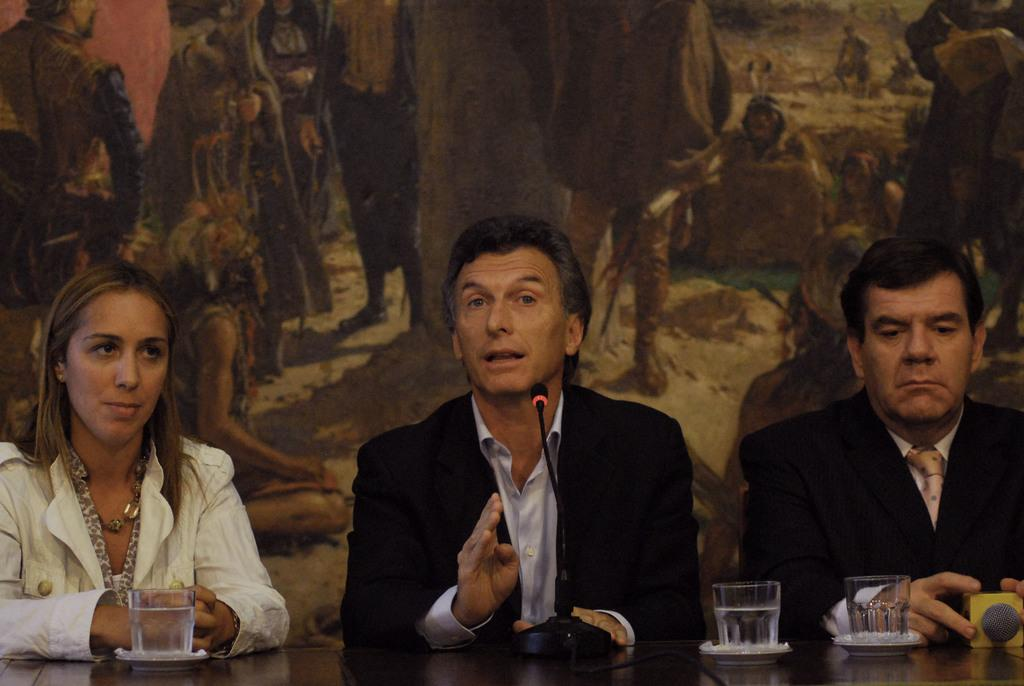How many people are sitting in the image? There are three people sitting in the center of the image. What is in front of the people? There is a table in front of the people. What objects can be seen on the table? Glasses and a mic are present on the table. What can be seen in the background of the image? There is a board in the background of the image. Can you hear the people laughing in the image? There is no sound or indication of laughter in the image; it is a still photograph. 